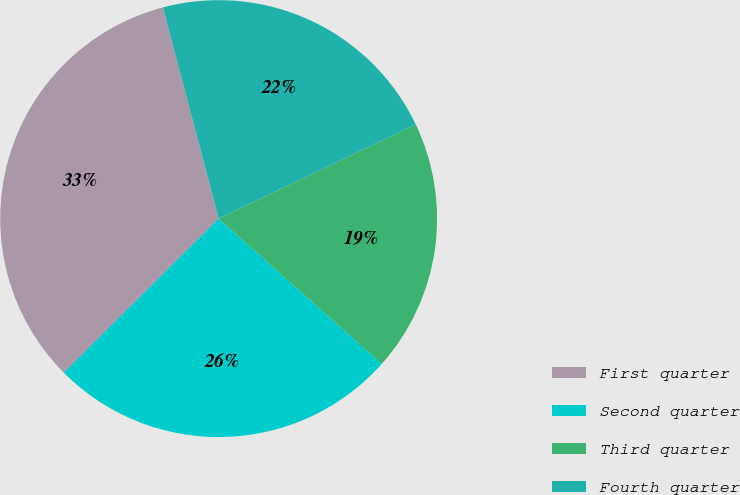<chart> <loc_0><loc_0><loc_500><loc_500><pie_chart><fcel>First quarter<fcel>Second quarter<fcel>Third quarter<fcel>Fourth quarter<nl><fcel>33.36%<fcel>25.95%<fcel>18.69%<fcel>22.01%<nl></chart> 